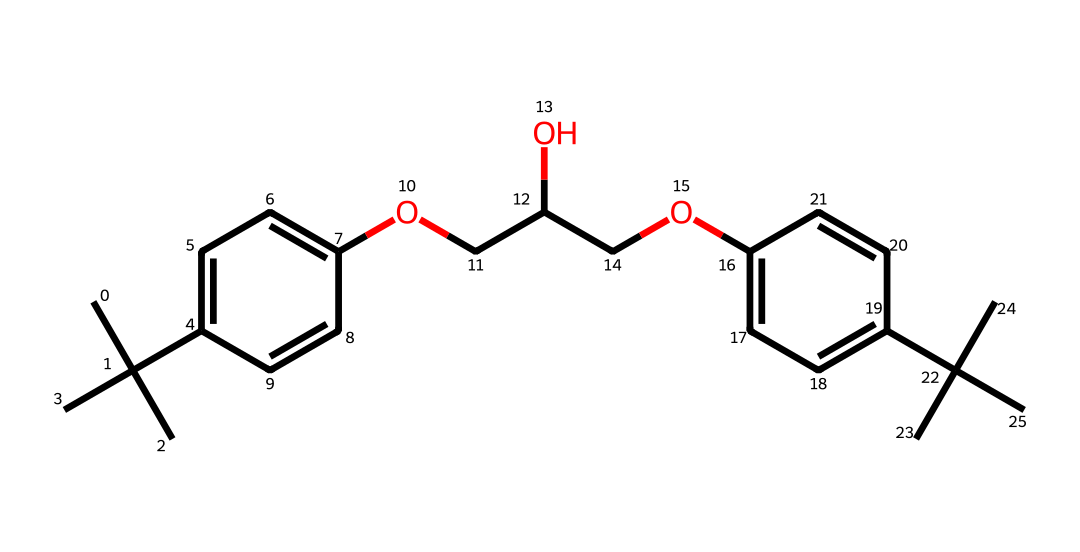What is the molecular formula of this adhesive? To determine the molecular formula, count the number of carbon (C), hydrogen (H), and oxygen (O) atoms in the SMILES representation. From the structure, there are 24 carbon atoms, 38 hydrogen atoms, and 4 oxygen atoms. Thus, the molecular formula is C24H38O4.
Answer: C24H38O4 How many rings are present in the chemical structure? The structure shows two distinct aromatic rings (each represented by the cyclic carbon characters in the SMILES) as seen in the "C1=CC" and "C2=CC" sections. Therefore, there are 2 rings.
Answer: 2 What type of functional groups are present in this adhesive? By analyzing the SMILES, we can identify the functional groups, including alcohol (–OH) indicated by "O" and ethers (–O–) seen in "OCC" and "COC". Thus, the functional groups present are alcohols and ethers.
Answer: alcohols and ethers What is the primary use of this adhesive in ceramics? The adhesive's chemical structure suggests it is complex and provides good bonding properties, which makes it suitable for restoring ceramics and attaching fragments firmly.
Answer: restoration of ceramics How does the presence of oxygen affect the adhesive properties of this chemical? Oxygen within functional groups like alcohols and ethers contributes to hydrogen bonding, increasing adhesion strength and durability, which are advantageous in restoring delicate artifacts.
Answer: increases adhesion strength What kind of interactions might this chemical facilitate with ceramic materials? The functional groups in the adhesive can form hydrogen bonds and possibly covalent interactions with ceramic substrates, creating a strong bond that effectively restores materials.
Answer: strong bond formation 